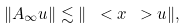<formula> <loc_0><loc_0><loc_500><loc_500>\| A _ { \infty } u \| \lesssim \| \ < x \ > u \| ,</formula> 